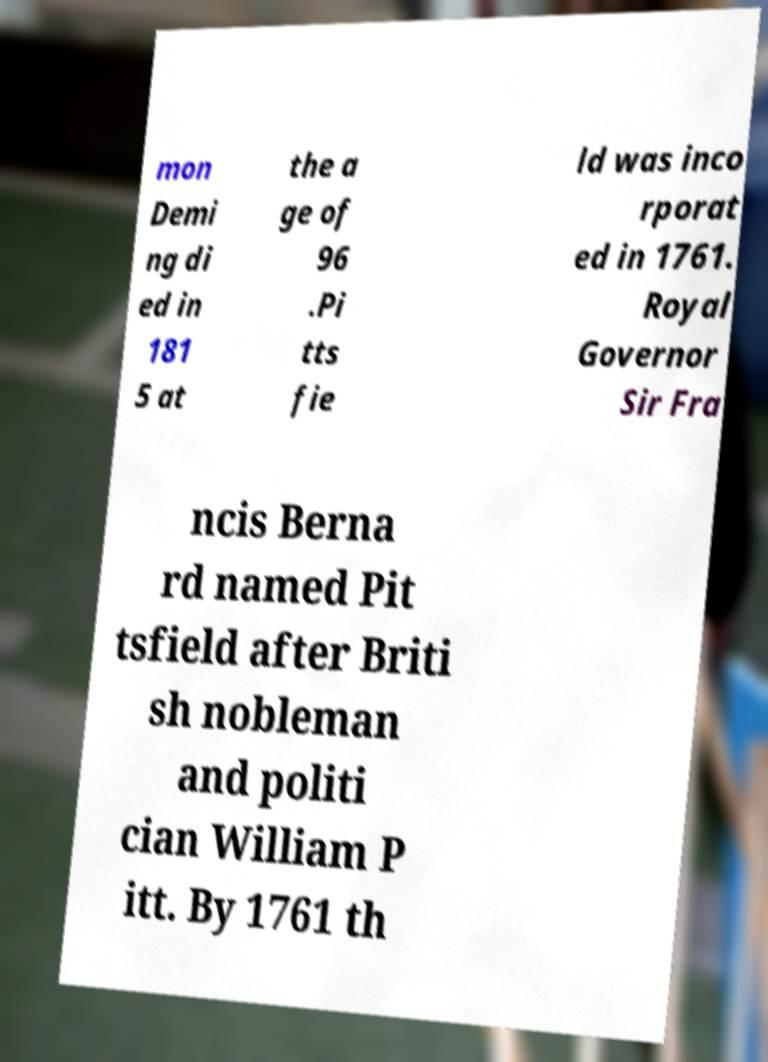For documentation purposes, I need the text within this image transcribed. Could you provide that? mon Demi ng di ed in 181 5 at the a ge of 96 .Pi tts fie ld was inco rporat ed in 1761. Royal Governor Sir Fra ncis Berna rd named Pit tsfield after Briti sh nobleman and politi cian William P itt. By 1761 th 